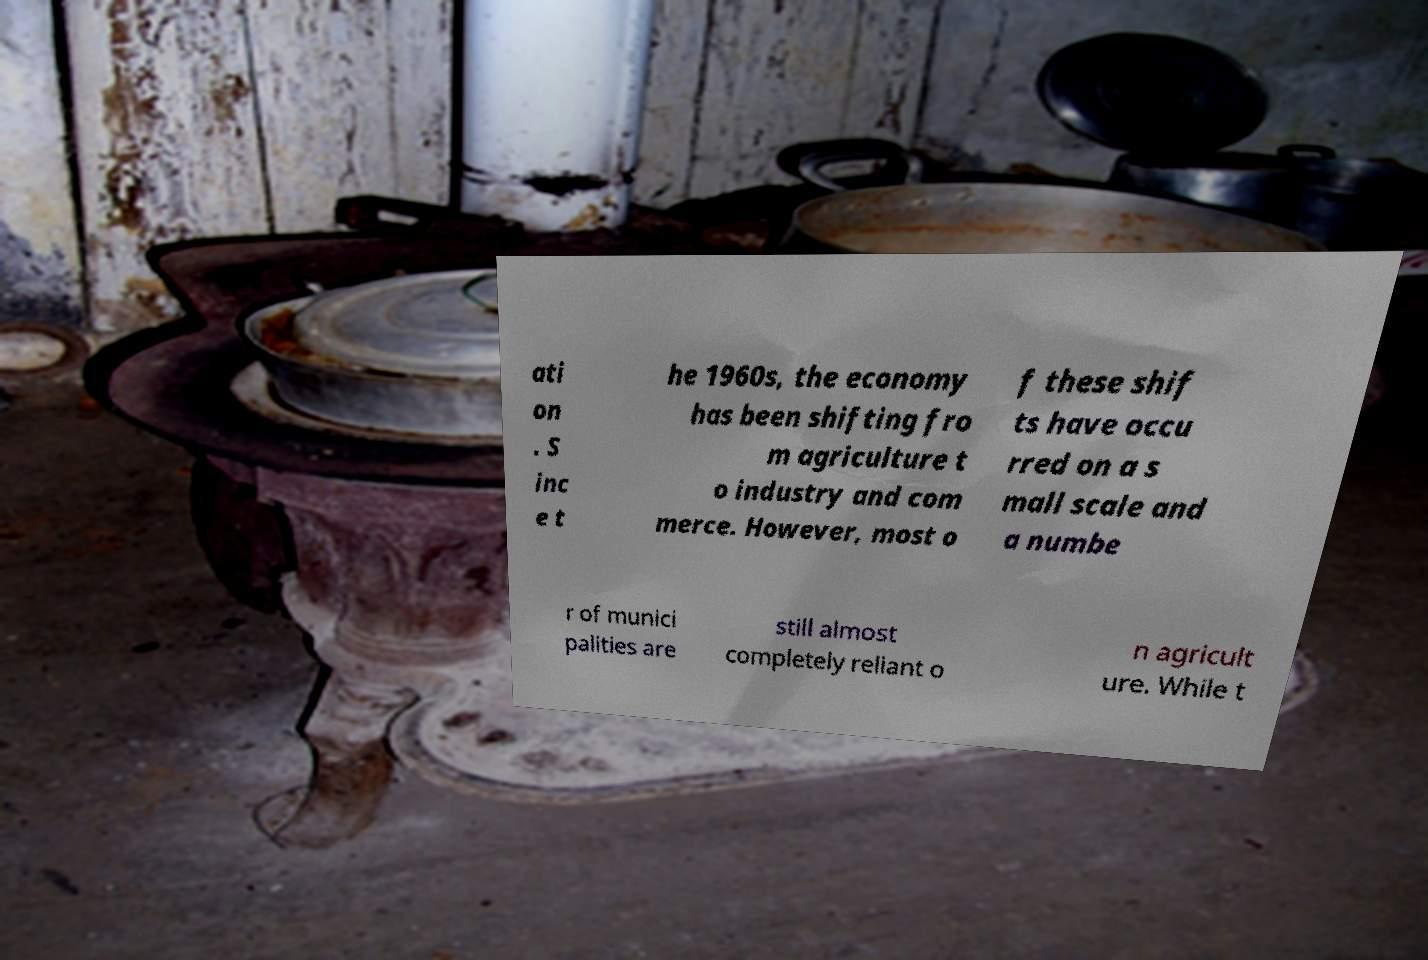Could you assist in decoding the text presented in this image and type it out clearly? ati on . S inc e t he 1960s, the economy has been shifting fro m agriculture t o industry and com merce. However, most o f these shif ts have occu rred on a s mall scale and a numbe r of munici palities are still almost completely reliant o n agricult ure. While t 